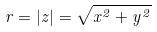<formula> <loc_0><loc_0><loc_500><loc_500>r = | z | = \sqrt { x ^ { 2 } + y ^ { 2 } }</formula> 